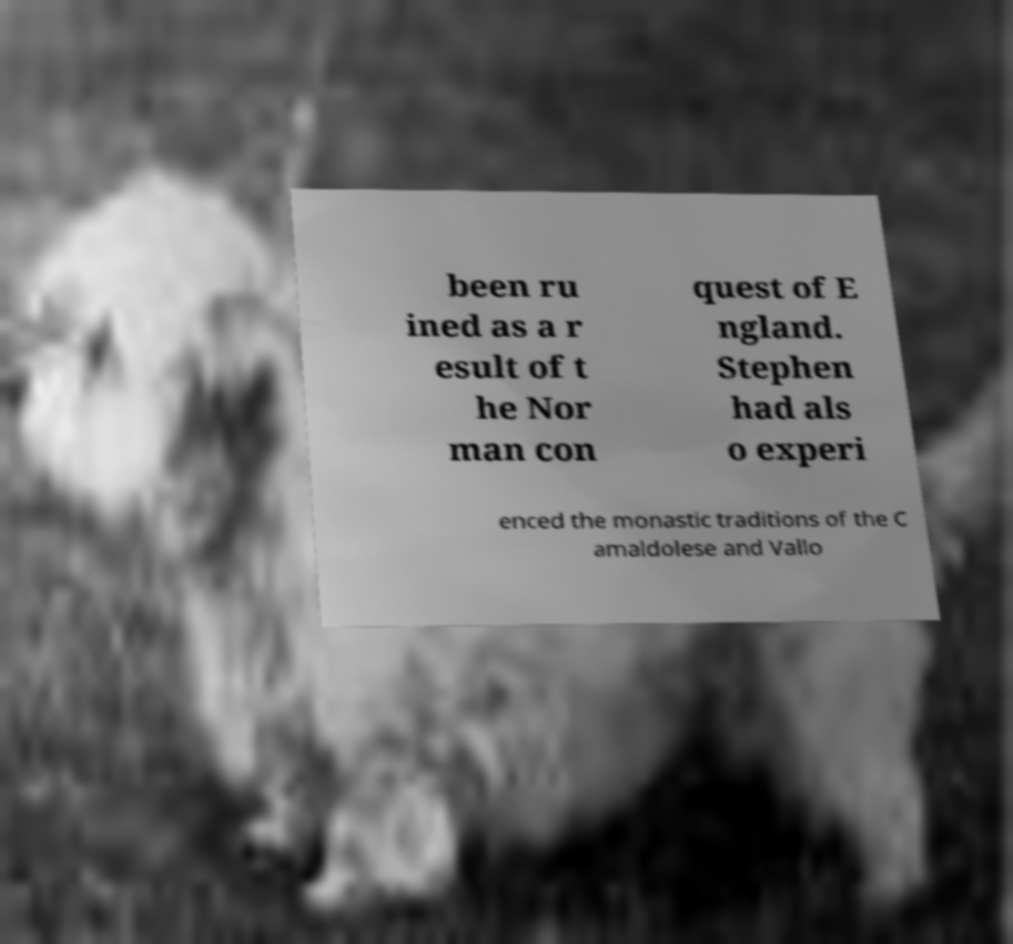Could you assist in decoding the text presented in this image and type it out clearly? been ru ined as a r esult of t he Nor man con quest of E ngland. Stephen had als o experi enced the monastic traditions of the C amaldolese and Vallo 